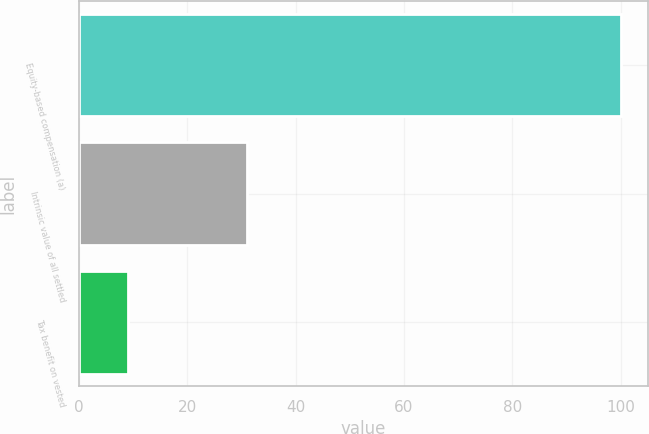Convert chart to OTSL. <chart><loc_0><loc_0><loc_500><loc_500><bar_chart><fcel>Equity-based compensation (a)<fcel>Intrinsic value of all settled<fcel>Tax benefit on vested<nl><fcel>100<fcel>31<fcel>9<nl></chart> 